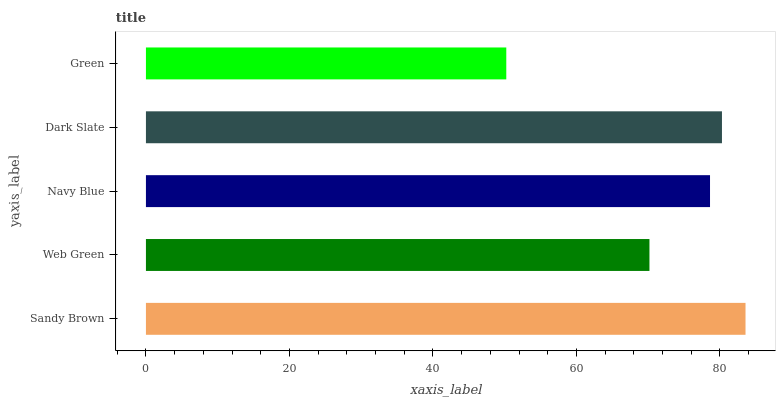Is Green the minimum?
Answer yes or no. Yes. Is Sandy Brown the maximum?
Answer yes or no. Yes. Is Web Green the minimum?
Answer yes or no. No. Is Web Green the maximum?
Answer yes or no. No. Is Sandy Brown greater than Web Green?
Answer yes or no. Yes. Is Web Green less than Sandy Brown?
Answer yes or no. Yes. Is Web Green greater than Sandy Brown?
Answer yes or no. No. Is Sandy Brown less than Web Green?
Answer yes or no. No. Is Navy Blue the high median?
Answer yes or no. Yes. Is Navy Blue the low median?
Answer yes or no. Yes. Is Sandy Brown the high median?
Answer yes or no. No. Is Dark Slate the low median?
Answer yes or no. No. 